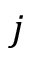Convert formula to latex. <formula><loc_0><loc_0><loc_500><loc_500>j</formula> 